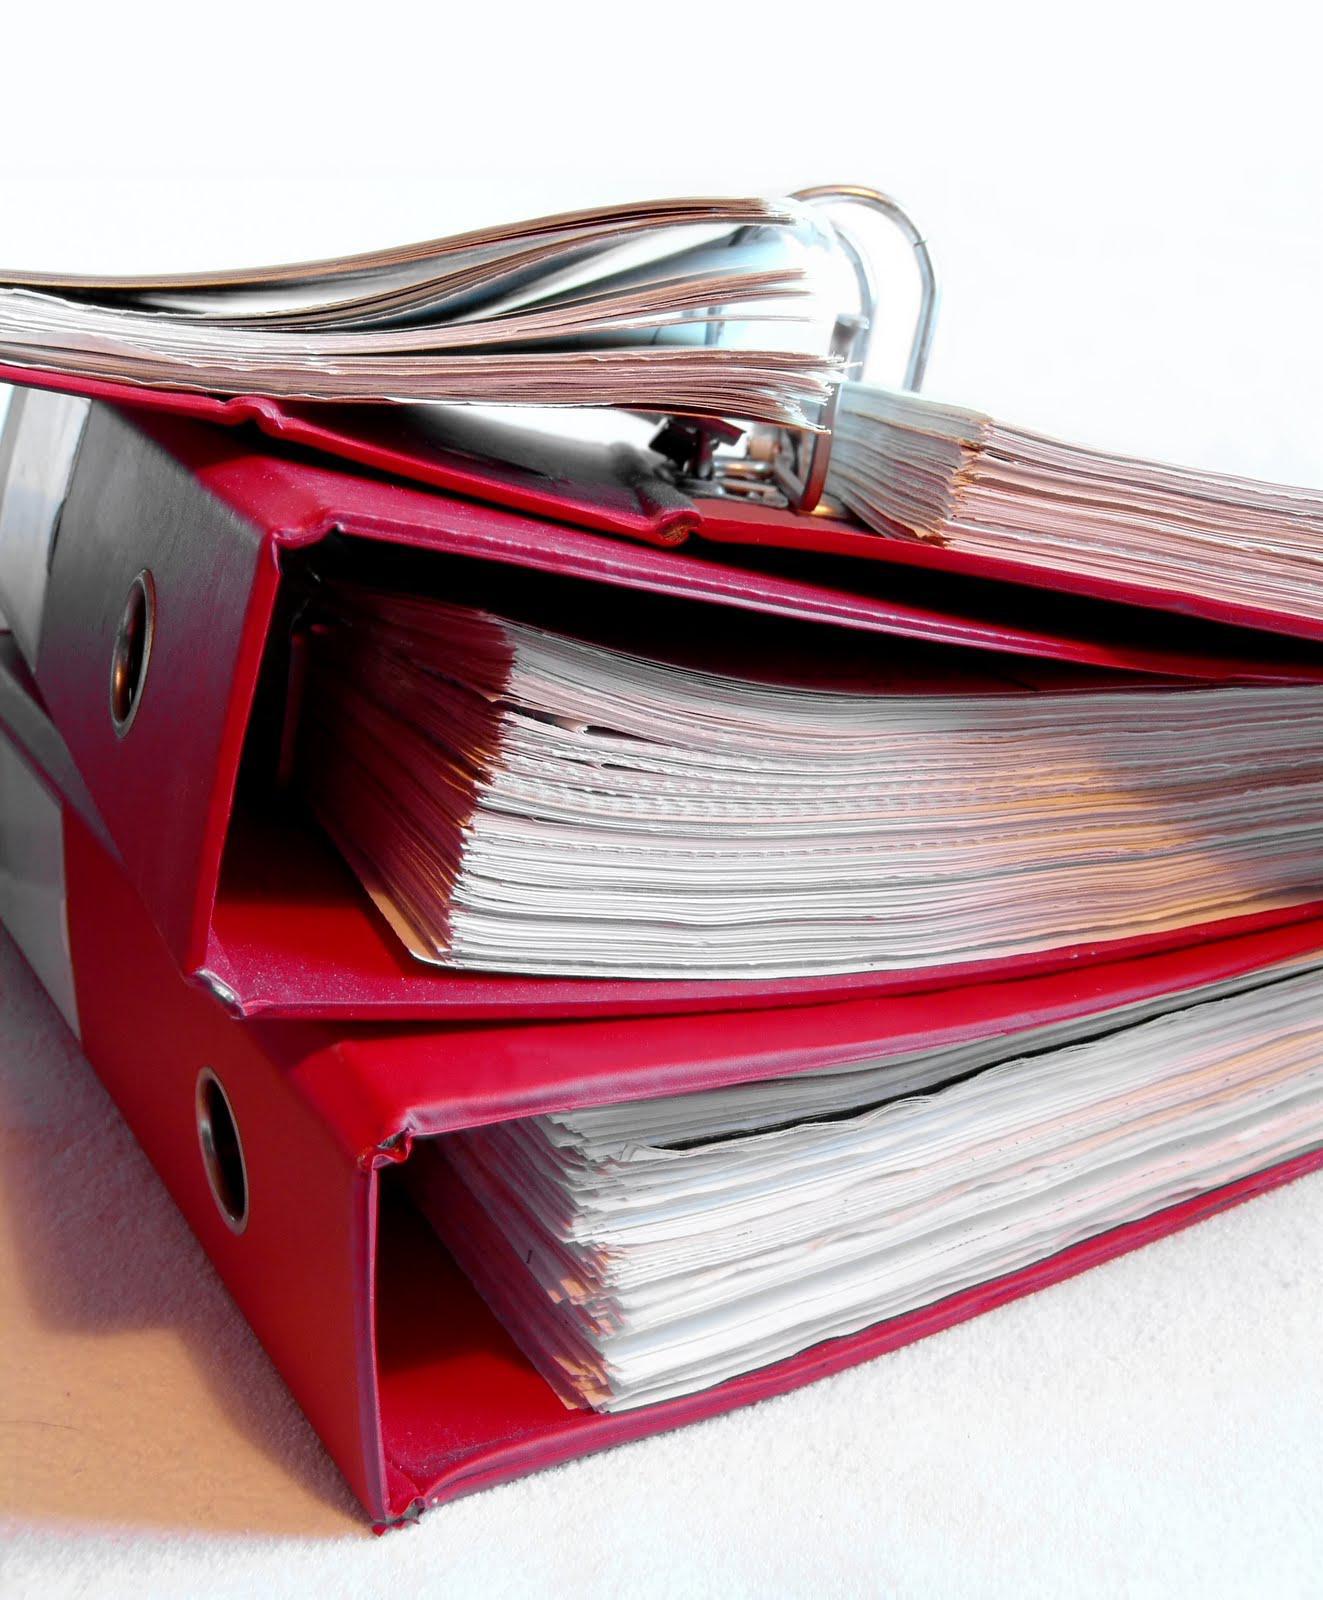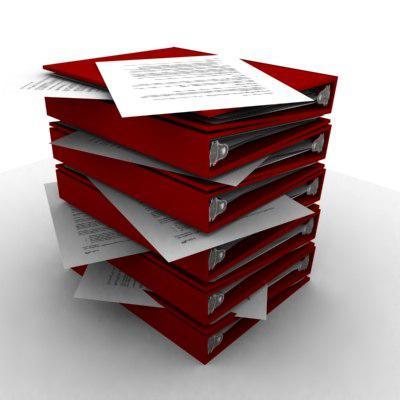The first image is the image on the left, the second image is the image on the right. Analyze the images presented: Is the assertion "Multiple black and orange binders are stacked on top of one another" valid? Answer yes or no. No. The first image is the image on the left, the second image is the image on the right. Assess this claim about the two images: "There are stacks of binders with orange mixed with black". Correct or not? Answer yes or no. No. 